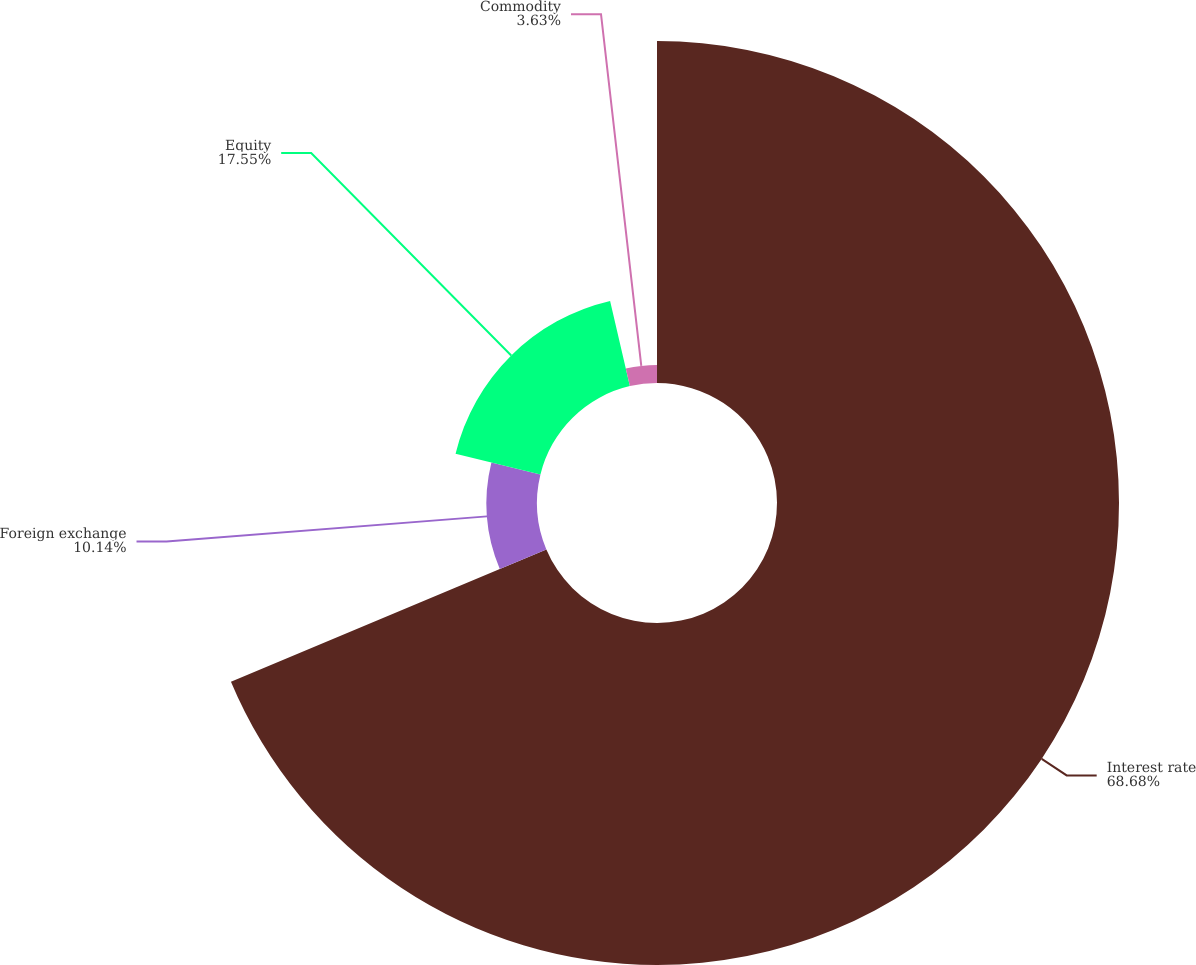<chart> <loc_0><loc_0><loc_500><loc_500><pie_chart><fcel>Interest rate<fcel>Foreign exchange<fcel>Equity<fcel>Commodity<nl><fcel>68.68%<fcel>10.14%<fcel>17.55%<fcel>3.63%<nl></chart> 